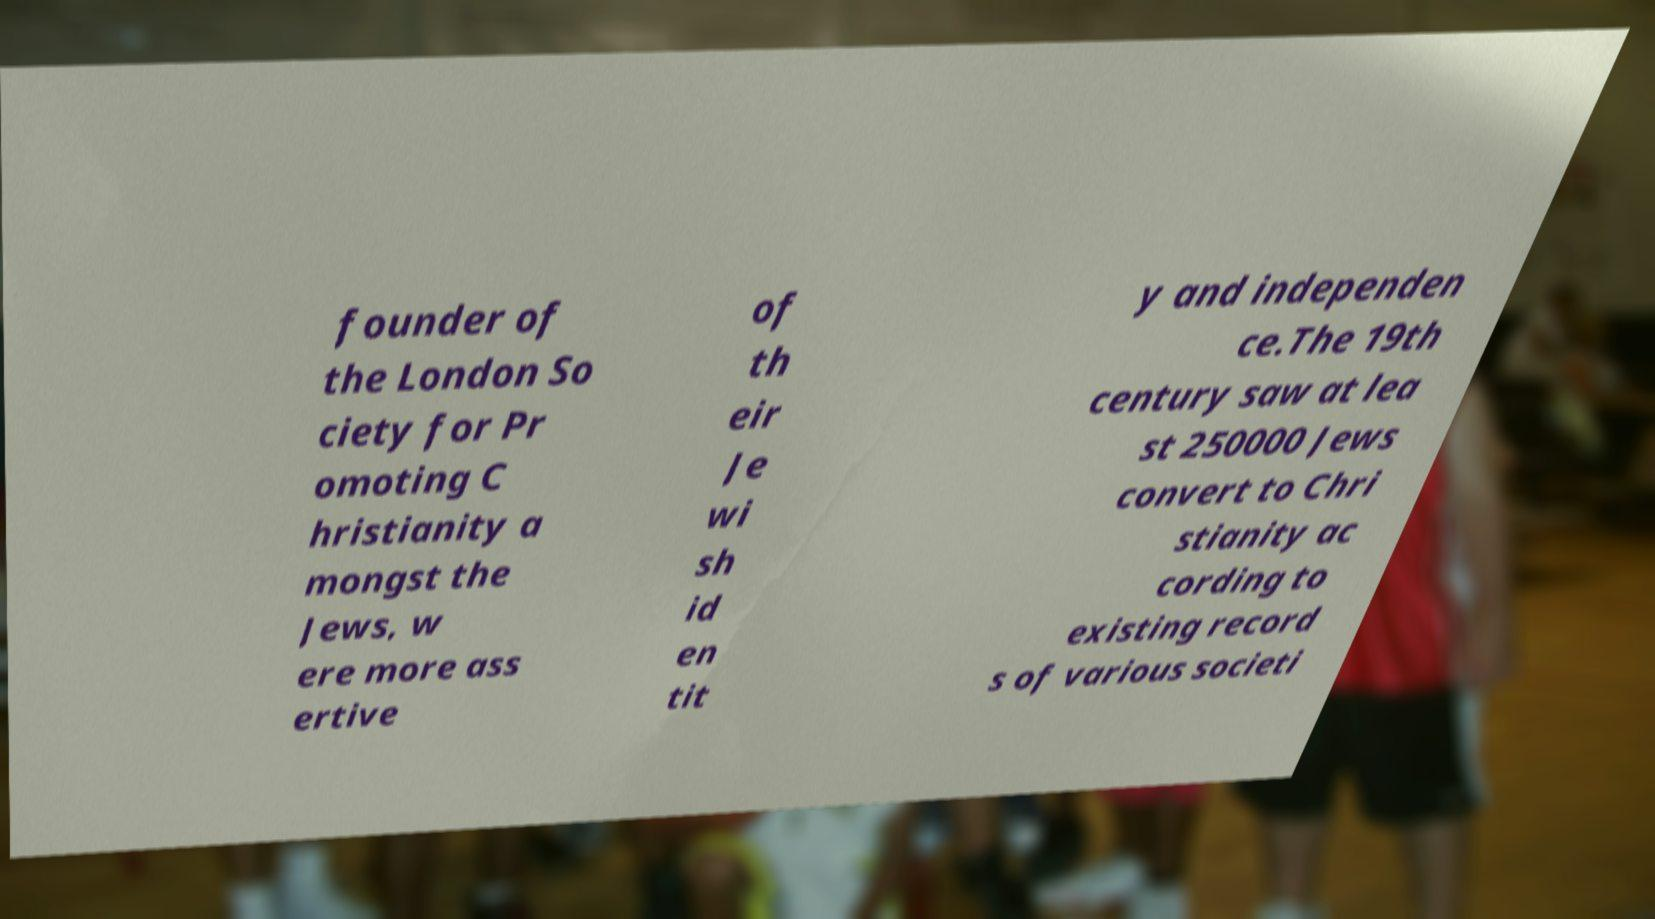Can you accurately transcribe the text from the provided image for me? founder of the London So ciety for Pr omoting C hristianity a mongst the Jews, w ere more ass ertive of th eir Je wi sh id en tit y and independen ce.The 19th century saw at lea st 250000 Jews convert to Chri stianity ac cording to existing record s of various societi 